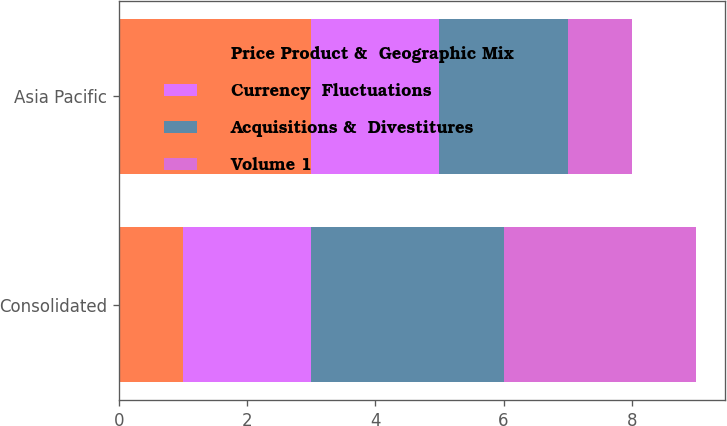Convert chart to OTSL. <chart><loc_0><loc_0><loc_500><loc_500><stacked_bar_chart><ecel><fcel>Consolidated<fcel>Asia Pacific<nl><fcel>Price Product &  Geographic Mix<fcel>1<fcel>3<nl><fcel>Currency  Fluctuations<fcel>2<fcel>2<nl><fcel>Acquisitions &  Divestitures<fcel>3<fcel>2<nl><fcel>Volume 1<fcel>3<fcel>1<nl></chart> 